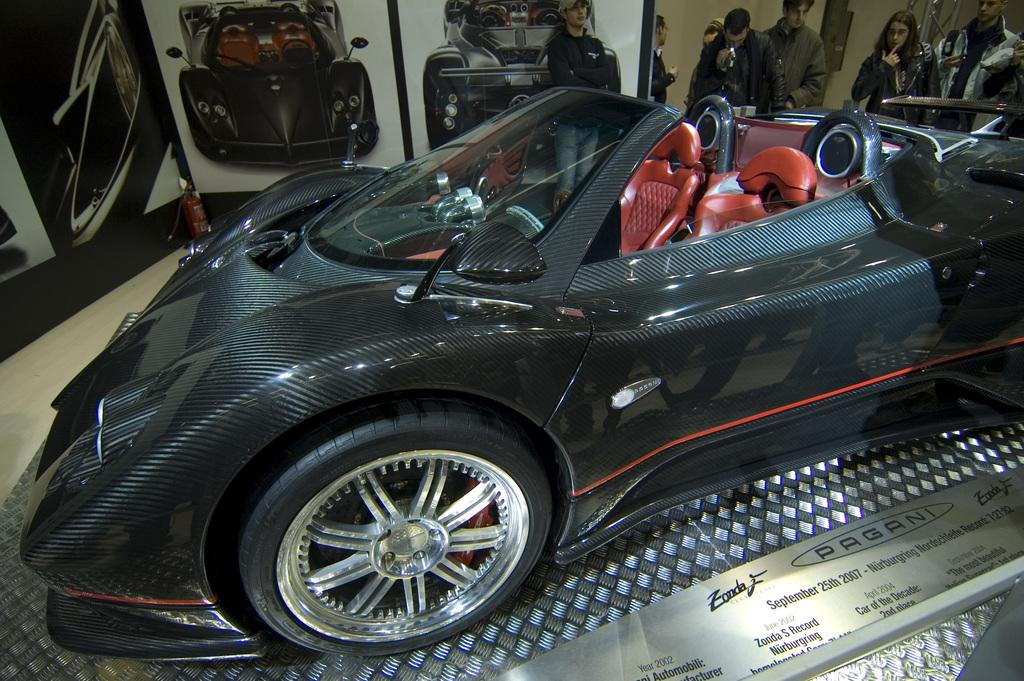What is the main subject of the image? There is a car in the image. What is written or displayed on the platform in the image? There is text on a platform in the image. Can you describe the background of the image? There are people, a fire extinguisher, photos of cars, and other objects present in the background of the image. Where are the dolls placed in the image? There are no dolls present in the image. What level of difficulty is the image set at? The image does not have a level of difficulty, as it is a static representation and not a game or challenge. 